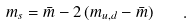<formula> <loc_0><loc_0><loc_500><loc_500>m _ { s } = \bar { m } - 2 \, ( m _ { u , d } - \bar { m } ) \quad .</formula> 